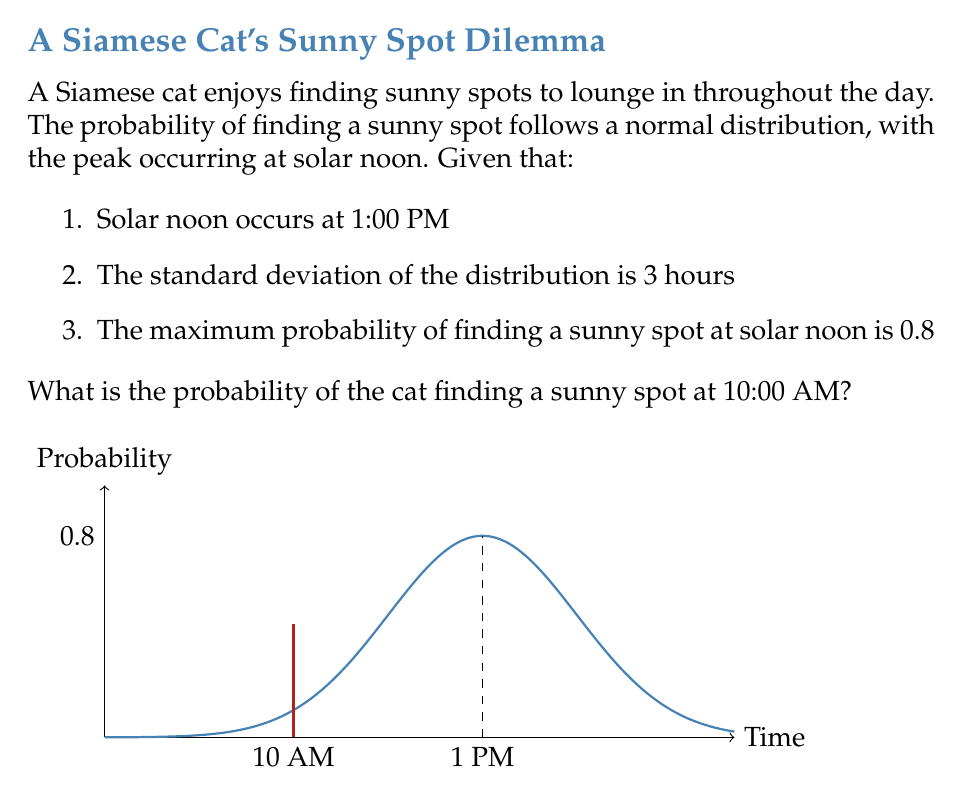What is the answer to this math problem? Let's approach this step-by-step:

1) We're dealing with a normal distribution where:
   - Mean (μ) = 13 (1:00 PM in 24-hour format)
   - Standard deviation (σ) = 3 hours
   - Maximum probability at mean = 0.8

2) The probability density function for a normal distribution is:

   $$f(x) = \frac{1}{\sigma\sqrt{2\pi}} e^{-\frac{1}{2}(\frac{x-\mu}{\sigma})^2}$$

3) However, our distribution is scaled so that the maximum is 0.8 instead of 1. So we need to multiply the standard normal distribution by 0.8:

   $$f(x) = 0.8 \cdot \frac{1}{\sigma\sqrt{2\pi}} e^{-\frac{1}{2}(\frac{x-\mu}{\sigma})^2}$$

4) We want to find the probability at 10:00 AM, which is 10 in 24-hour format. Let's plug in our values:

   $$f(10) = 0.8 \cdot \frac{1}{3\sqrt{2\pi}} e^{-\frac{1}{2}(\frac{10-13}{3})^2}$$

5) Simplifying:
   
   $$f(10) = 0.8 \cdot \frac{1}{3\sqrt{2\pi}} e^{-\frac{1}{2}(-1)^2}$$
   $$f(10) = 0.8 \cdot \frac{1}{3\sqrt{2\pi}} e^{-\frac{1}{2}}$$

6) Calculating this value:
   
   $$f(10) \approx 0.5301$$

Therefore, the probability of the cat finding a sunny spot at 10:00 AM is approximately 0.5301 or 53.01%.
Answer: 0.5301 